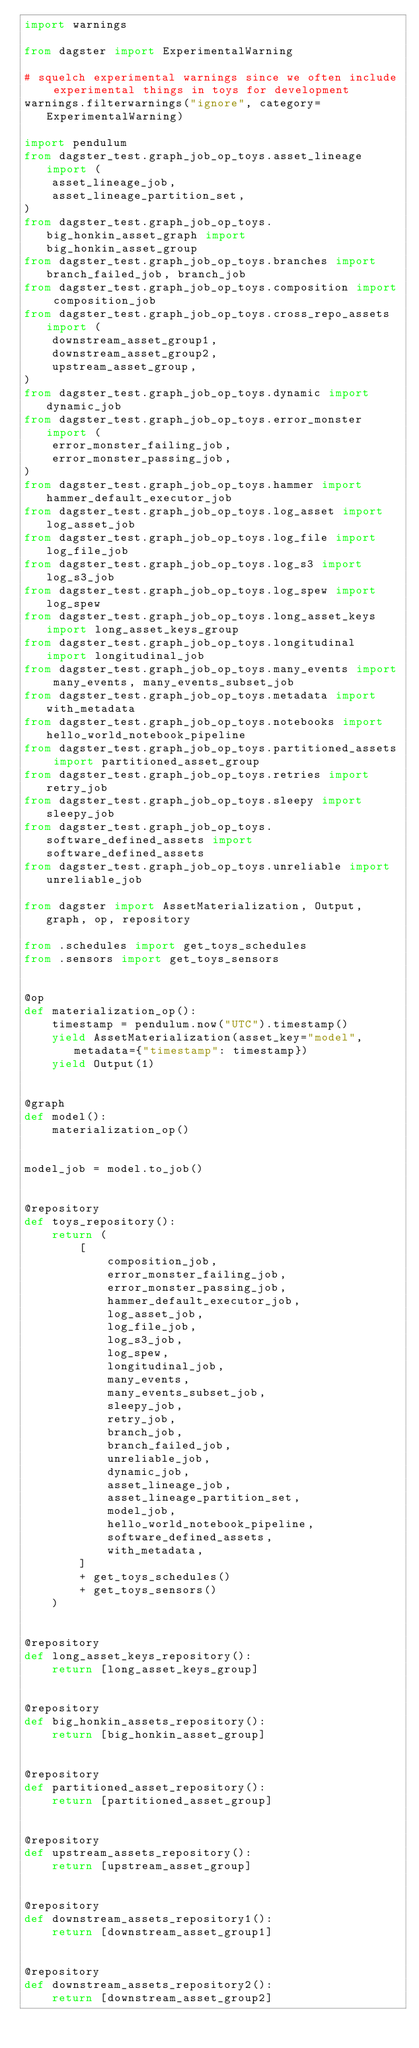<code> <loc_0><loc_0><loc_500><loc_500><_Python_>import warnings

from dagster import ExperimentalWarning

# squelch experimental warnings since we often include experimental things in toys for development
warnings.filterwarnings("ignore", category=ExperimentalWarning)

import pendulum
from dagster_test.graph_job_op_toys.asset_lineage import (
    asset_lineage_job,
    asset_lineage_partition_set,
)
from dagster_test.graph_job_op_toys.big_honkin_asset_graph import big_honkin_asset_group
from dagster_test.graph_job_op_toys.branches import branch_failed_job, branch_job
from dagster_test.graph_job_op_toys.composition import composition_job
from dagster_test.graph_job_op_toys.cross_repo_assets import (
    downstream_asset_group1,
    downstream_asset_group2,
    upstream_asset_group,
)
from dagster_test.graph_job_op_toys.dynamic import dynamic_job
from dagster_test.graph_job_op_toys.error_monster import (
    error_monster_failing_job,
    error_monster_passing_job,
)
from dagster_test.graph_job_op_toys.hammer import hammer_default_executor_job
from dagster_test.graph_job_op_toys.log_asset import log_asset_job
from dagster_test.graph_job_op_toys.log_file import log_file_job
from dagster_test.graph_job_op_toys.log_s3 import log_s3_job
from dagster_test.graph_job_op_toys.log_spew import log_spew
from dagster_test.graph_job_op_toys.long_asset_keys import long_asset_keys_group
from dagster_test.graph_job_op_toys.longitudinal import longitudinal_job
from dagster_test.graph_job_op_toys.many_events import many_events, many_events_subset_job
from dagster_test.graph_job_op_toys.metadata import with_metadata
from dagster_test.graph_job_op_toys.notebooks import hello_world_notebook_pipeline
from dagster_test.graph_job_op_toys.partitioned_assets import partitioned_asset_group
from dagster_test.graph_job_op_toys.retries import retry_job
from dagster_test.graph_job_op_toys.sleepy import sleepy_job
from dagster_test.graph_job_op_toys.software_defined_assets import software_defined_assets
from dagster_test.graph_job_op_toys.unreliable import unreliable_job

from dagster import AssetMaterialization, Output, graph, op, repository

from .schedules import get_toys_schedules
from .sensors import get_toys_sensors


@op
def materialization_op():
    timestamp = pendulum.now("UTC").timestamp()
    yield AssetMaterialization(asset_key="model", metadata={"timestamp": timestamp})
    yield Output(1)


@graph
def model():
    materialization_op()


model_job = model.to_job()


@repository
def toys_repository():
    return (
        [
            composition_job,
            error_monster_failing_job,
            error_monster_passing_job,
            hammer_default_executor_job,
            log_asset_job,
            log_file_job,
            log_s3_job,
            log_spew,
            longitudinal_job,
            many_events,
            many_events_subset_job,
            sleepy_job,
            retry_job,
            branch_job,
            branch_failed_job,
            unreliable_job,
            dynamic_job,
            asset_lineage_job,
            asset_lineage_partition_set,
            model_job,
            hello_world_notebook_pipeline,
            software_defined_assets,
            with_metadata,
        ]
        + get_toys_schedules()
        + get_toys_sensors()
    )


@repository
def long_asset_keys_repository():
    return [long_asset_keys_group]


@repository
def big_honkin_assets_repository():
    return [big_honkin_asset_group]


@repository
def partitioned_asset_repository():
    return [partitioned_asset_group]


@repository
def upstream_assets_repository():
    return [upstream_asset_group]


@repository
def downstream_assets_repository1():
    return [downstream_asset_group1]


@repository
def downstream_assets_repository2():
    return [downstream_asset_group2]
</code> 